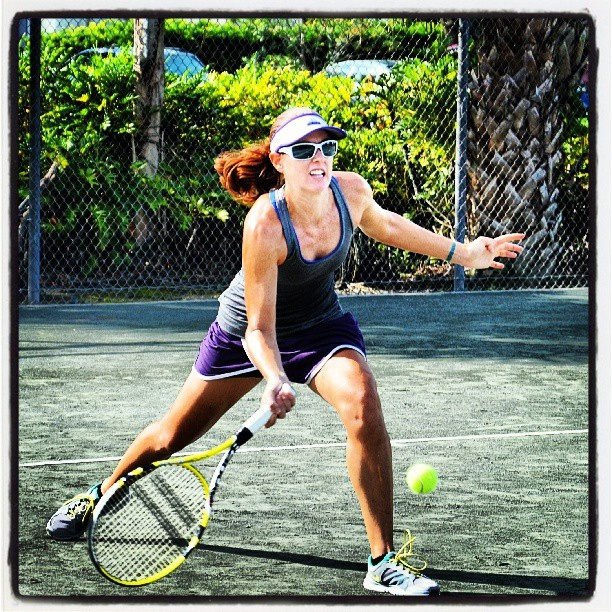Describe the objects in this image and their specific colors. I can see people in white, black, and tan tones, tennis racket in white, beige, black, darkgray, and gray tones, and sports ball in white, beige, lime, khaki, and lightgreen tones in this image. 